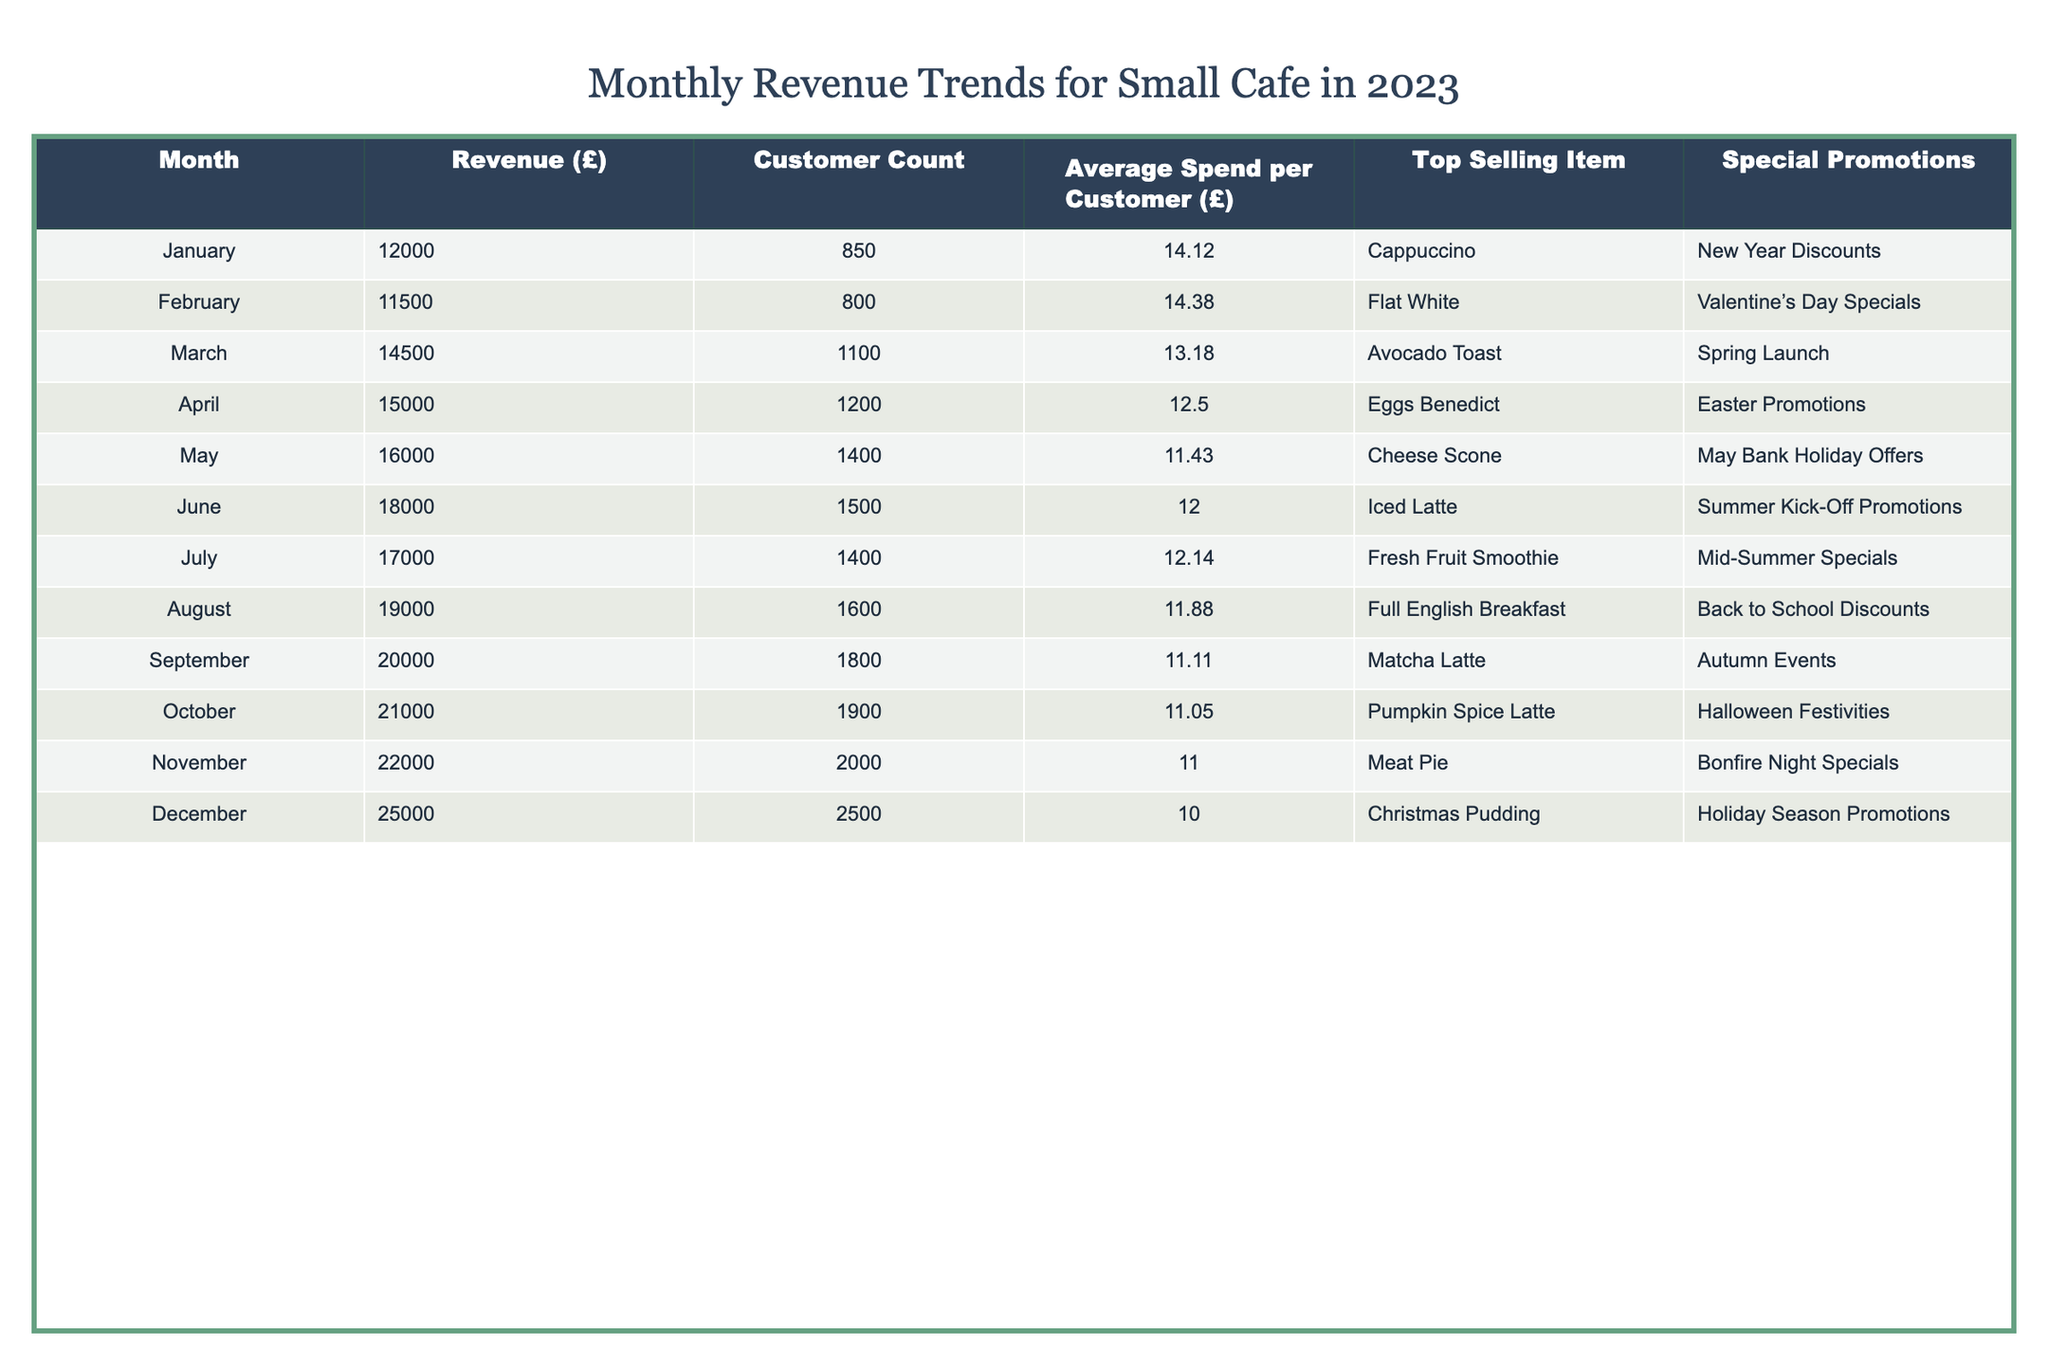What was the highest revenue month in 2023? The table shows the revenue for each month. December has the highest revenue at £25,000.
Answer: £25,000 What was the average spend per customer in March? In March, the average spend per customer is listed as £13.18.
Answer: £13.18 How many customers did the cafe have in November? The table indicates that in November, the cafe had 2,000 customers.
Answer: 2,000 Which month had the lowest average spend per customer? The average spends are compared across months, and December has the lowest at £10.00.
Answer: £10.00 What was the total revenue for the first half of the year (January to June)? The revenue for the first half is £12,000 (Jan) + £11,500 (Feb) + £14,500 (Mar) + £15,000 (Apr) + £16,000 (May) + £18,000 (Jun) = £87,000.
Answer: £87,000 Was the top selling item in October a matcha latte? According to the table, the top selling item in October is Pumpkin Spice Latte, not a matcha latte.
Answer: No In which month did the cafe see a revenue increase of £2,000 from the previous month? By examining the table, October shows an increase from September's £20,000 to £21,000, an increase of £1,000; however, November sees an increase to £22,000, which is also £2,000 from October.
Answer: November What percentage increase in revenue did the cafe see from January to March? The revenue in January was £12,000 and in March it was £14,500. The increase is (£14,500 - £12,000) / £12,000 * 100 = 20.83%.
Answer: 20.83% What was the average number of customers served from January to June? Total number of customers from January to June is 850 + 800 + 1100 + 1200 + 1400 + 1500 = 5050. The average is 5050 / 6 = 841.67.
Answer: 841.67 Was the "Back to School Discounts" promotion run in July? The table shows that the "Back to School Discounts" were in August, not July.
Answer: No 